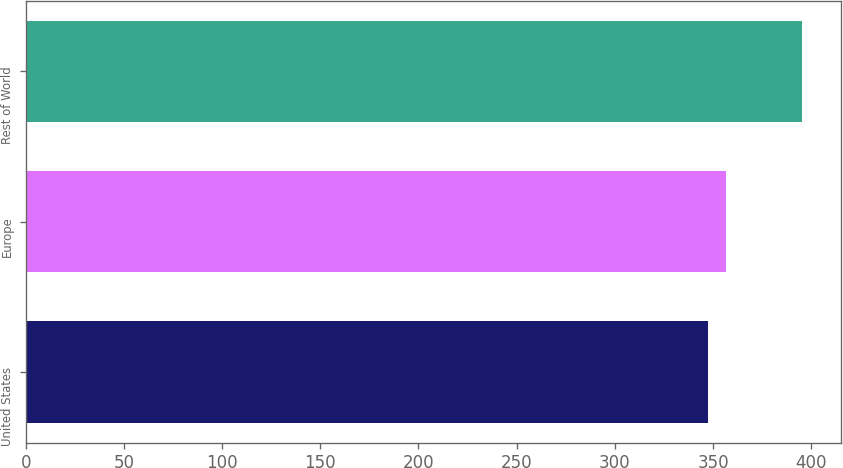Convert chart. <chart><loc_0><loc_0><loc_500><loc_500><bar_chart><fcel>United States<fcel>Europe<fcel>Rest of World<nl><fcel>347.6<fcel>356.4<fcel>395.5<nl></chart> 